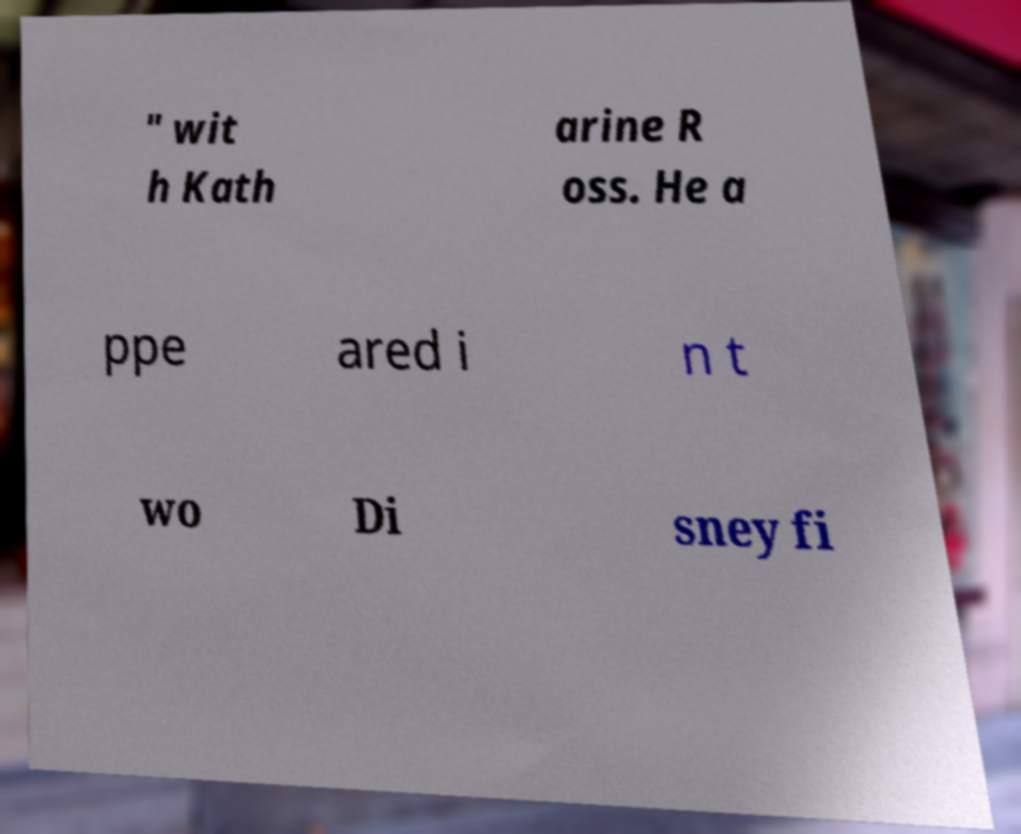Could you extract and type out the text from this image? " wit h Kath arine R oss. He a ppe ared i n t wo Di sney fi 